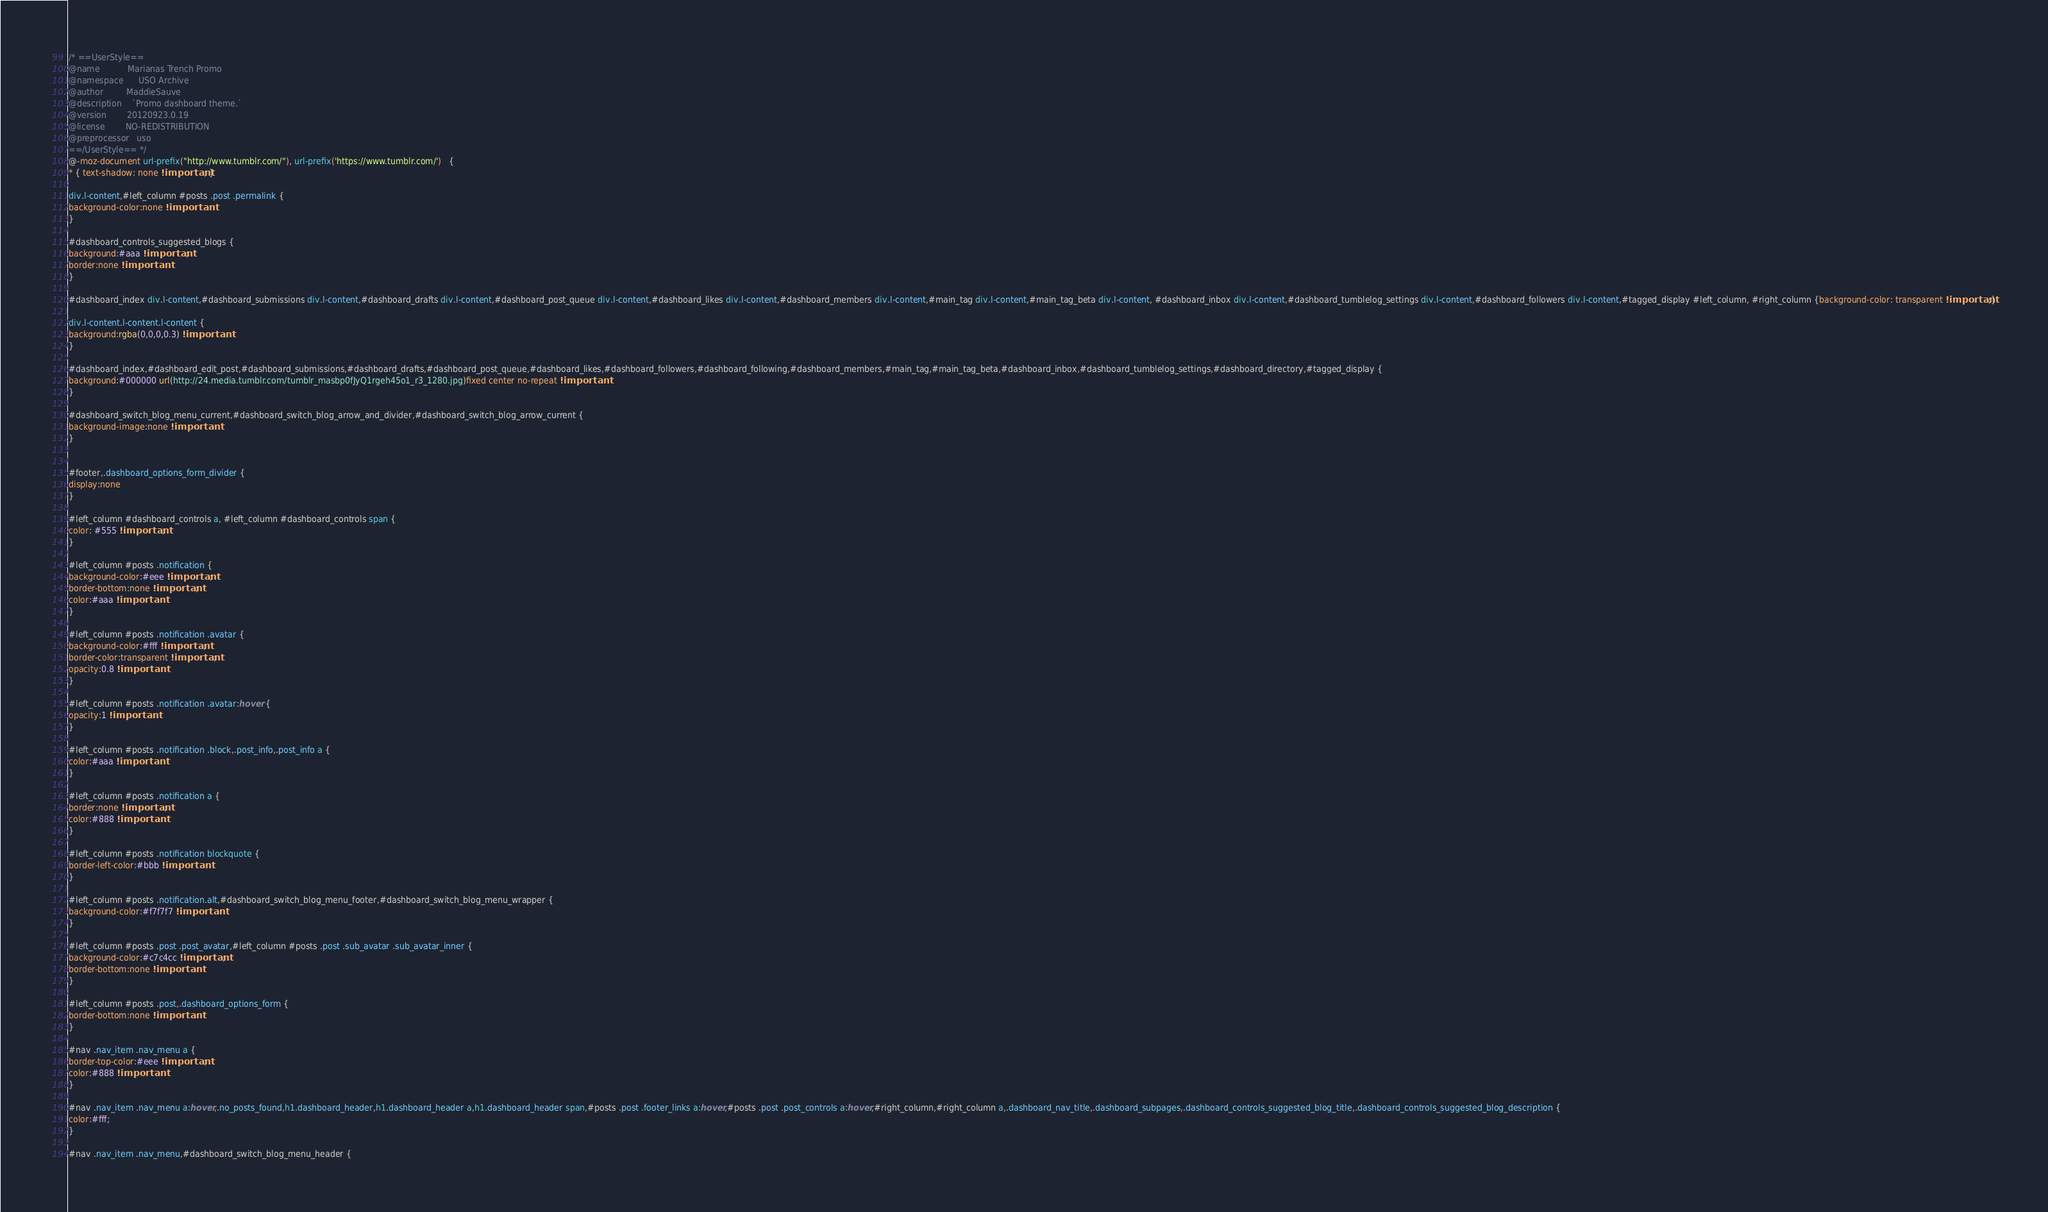<code> <loc_0><loc_0><loc_500><loc_500><_CSS_>/* ==UserStyle==
@name           Marianas Trench Promo
@namespace      USO Archive
@author         MaddieSauve
@description    `Promo dashboard theme.`
@version        20120923.0.19
@license        NO-REDISTRIBUTION
@preprocessor   uso
==/UserStyle== */
@-moz-document url-prefix("http://www.tumblr.com/"), url-prefix('https://www.tumblr.com/')   {
* { text-shadow: none !important; }

div.l-content,#left_column #posts .post .permalink {
background-color:none !important
}

#dashboard_controls_suggested_blogs {
background:#aaa !important;
border:none !important
}

#dashboard_index div.l-content,#dashboard_submissions div.l-content,#dashboard_drafts div.l-content,#dashboard_post_queue div.l-content,#dashboard_likes div.l-content,#dashboard_members div.l-content,#main_tag div.l-content,#main_tag_beta div.l-content, #dashboard_inbox div.l-content,#dashboard_tumblelog_settings div.l-content,#dashboard_followers div.l-content,#tagged_display #left_column, #right_column {background-color: transparent !important;}

div.l-content.l-content.l-content {
background:rgba(0,0,0,0.3) !important
}

#dashboard_index,#dashboard_edit_post,#dashboard_submissions,#dashboard_drafts,#dashboard_post_queue,#dashboard_likes,#dashboard_followers,#dashboard_following,#dashboard_members,#main_tag,#main_tag_beta,#dashboard_inbox,#dashboard_tumblelog_settings,#dashboard_directory,#tagged_display {
background:#000000 url(http://24.media.tumblr.com/tumblr_masbp0fJyQ1rgeh45o1_r3_1280.jpg)fixed center no-repeat !important
}

#dashboard_switch_blog_menu_current,#dashboard_switch_blog_arrow_and_divider,#dashboard_switch_blog_arrow_current {
background-image:none !important
}


#footer,.dashboard_options_form_divider {
display:none
}

#left_column #dashboard_controls a, #left_column #dashboard_controls span {
color: #555 !important;
}

#left_column #posts .notification {
background-color:#eee !important;
border-bottom:none !important;
color:#aaa !important
}

#left_column #posts .notification .avatar {
background-color:#fff !important;
border-color:transparent !important;
opacity:0.8 !important
}

#left_column #posts .notification .avatar:hover {
opacity:1 !important
}

#left_column #posts .notification .block,.post_info,.post_info a {
color:#aaa !important
}

#left_column #posts .notification a {
border:none !important;
color:#888 !important
}

#left_column #posts .notification blockquote {
border-left-color:#bbb !important
}

#left_column #posts .notification.alt,#dashboard_switch_blog_menu_footer,#dashboard_switch_blog_menu_wrapper {
background-color:#f7f7f7 !important
}

#left_column #posts .post .post_avatar,#left_column #posts .post .sub_avatar .sub_avatar_inner {
background-color:#c7c4cc !important;
border-bottom:none !important
}

#left_column #posts .post,.dashboard_options_form {
border-bottom:none !important
}

#nav .nav_item .nav_menu a {
border-top-color:#eee !important;
color:#888 !important
}

#nav .nav_item .nav_menu a:hover,.no_posts_found,h1.dashboard_header,h1.dashboard_header a,h1.dashboard_header span,#posts .post .footer_links a:hover,#posts .post .post_controls a:hover,#right_column,#right_column a,.dashboard_nav_title,.dashboard_subpages,.dashboard_controls_suggested_blog_title,.dashboard_controls_suggested_blog_description {
color:#fff;
}

#nav .nav_item .nav_menu,#dashboard_switch_blog_menu_header {</code> 